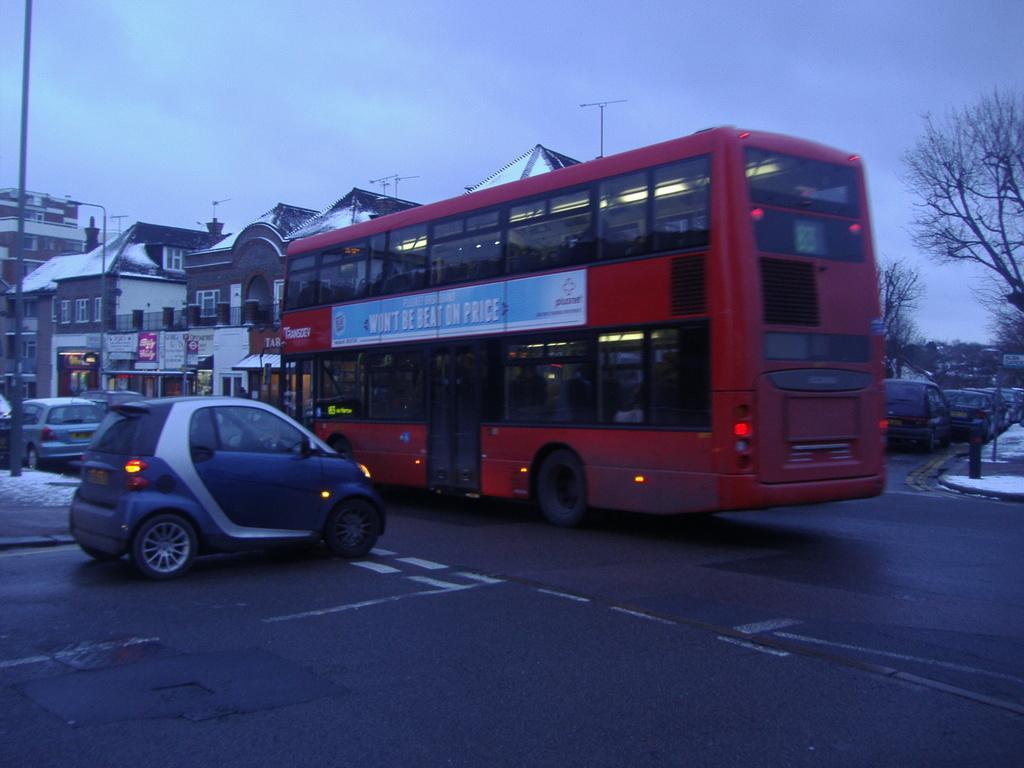Could you give a brief overview of what you see in this image? In this picture we can see red color double bus on the road. Here we can see electric car and other vehicles near to the pole. In the background we can see many buildings and street lights. On the right we can see trees. On the top we can see sky and clouds. On the left we can see snow. 